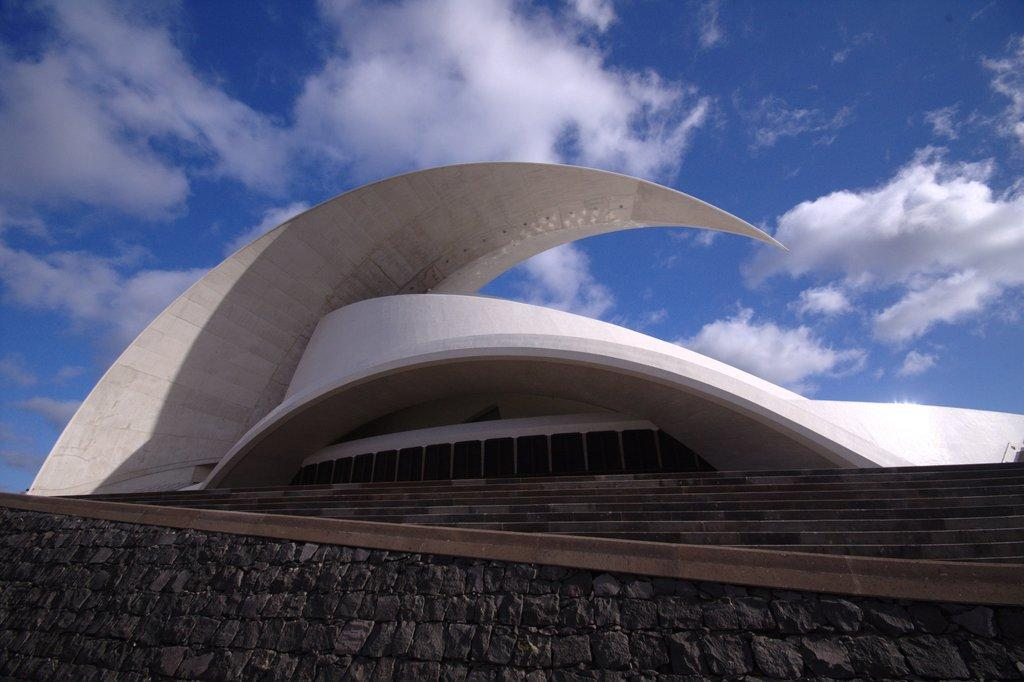What is the color of the building in the image? The building in the image is white. What architectural feature is present in the image? There are steps in the image. What can be seen in the background of the image? The sky is visible in the background of the image. What type of powder is being used to create the scent in the image? There is no mention of powder or scent in the image; it only features a white building and steps. 